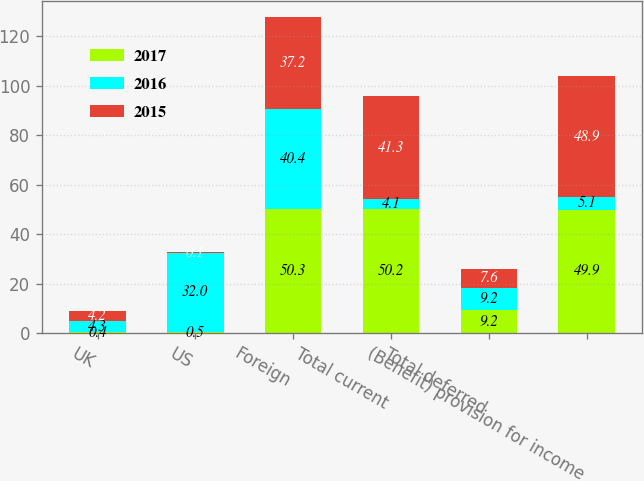<chart> <loc_0><loc_0><loc_500><loc_500><stacked_bar_chart><ecel><fcel>UK<fcel>US<fcel>Foreign<fcel>Total current<fcel>Total deferred<fcel>(Benefit) provision for income<nl><fcel>2017<fcel>0.4<fcel>0.5<fcel>50.3<fcel>50.2<fcel>9.2<fcel>49.9<nl><fcel>2016<fcel>4.3<fcel>32<fcel>40.4<fcel>4.1<fcel>9.2<fcel>5.1<nl><fcel>2015<fcel>4.2<fcel>0.1<fcel>37.2<fcel>41.3<fcel>7.6<fcel>48.9<nl></chart> 